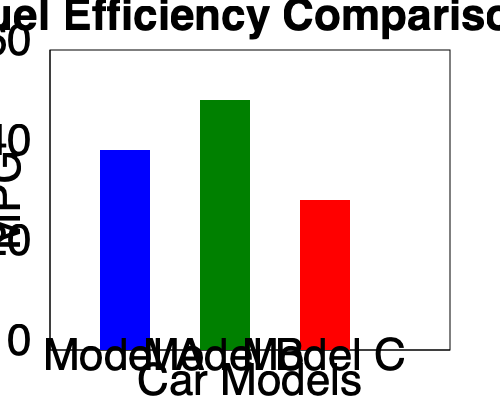Based on the fuel efficiency comparison graph, which car model would be the most cost-effective choice for a tech-savvy professional who frequently drives long distances for work and values both performance and economy? To determine the most cost-effective choice, we need to analyze the fuel efficiency of each model:

1. Interpret the graph:
   - The y-axis represents fuel efficiency in miles per gallon (MPG).
   - Higher bars indicate better fuel efficiency.

2. Analyze each model:
   - Model A (blue): Approximately 40 MPG
   - Model B (green): Approximately 50 MPG
   - Model C (red): Approximately 30 MPG

3. Consider the persona:
   - A tech-savvy professional who drives long distances
   - Values performance and economy

4. Evaluate the options:
   - Model B has the highest fuel efficiency at 50 MPG.
   - Higher MPG means less fuel consumption over long distances.
   - Better fuel efficiency translates to lower fuel costs.
   - Model B likely incorporates the latest fuel-saving technologies.

5. Conclusion:
   Model B offers the best balance of fuel efficiency and technology, making it the most cost-effective choice for a professional who drives frequently and values both performance and economy.
Answer: Model B 